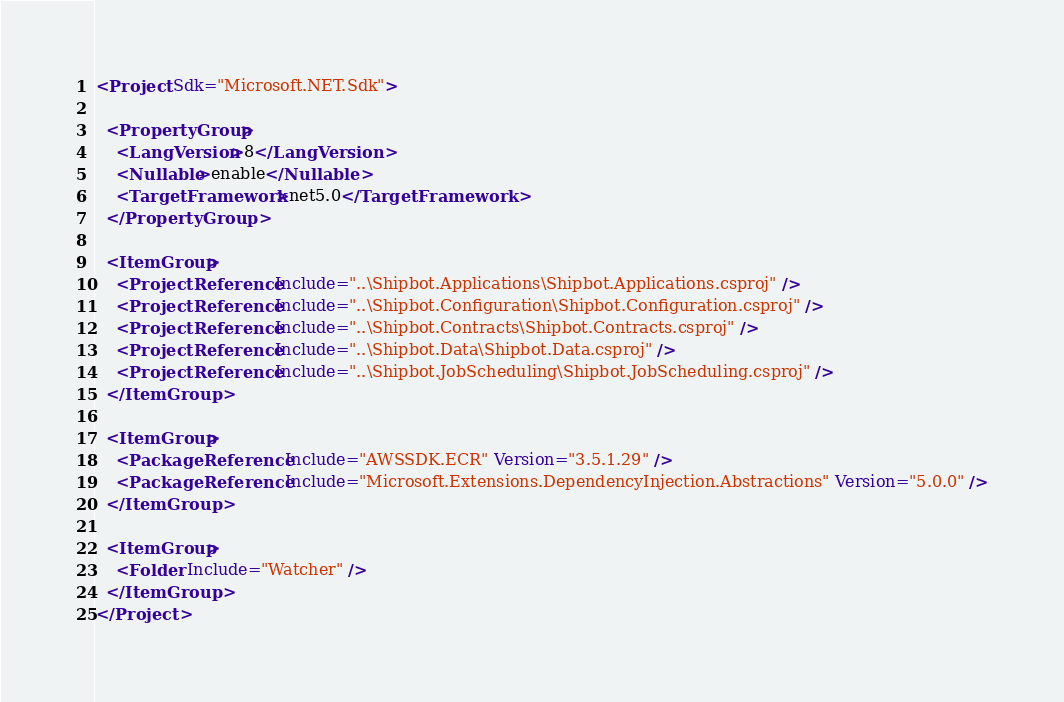Convert code to text. <code><loc_0><loc_0><loc_500><loc_500><_XML_><Project Sdk="Microsoft.NET.Sdk">

  <PropertyGroup>
    <LangVersion>8</LangVersion>
    <Nullable>enable</Nullable>
    <TargetFramework>net5.0</TargetFramework>
  </PropertyGroup>

  <ItemGroup>
    <ProjectReference Include="..\Shipbot.Applications\Shipbot.Applications.csproj" />
    <ProjectReference Include="..\Shipbot.Configuration\Shipbot.Configuration.csproj" />
    <ProjectReference Include="..\Shipbot.Contracts\Shipbot.Contracts.csproj" />
    <ProjectReference Include="..\Shipbot.Data\Shipbot.Data.csproj" />
    <ProjectReference Include="..\Shipbot.JobScheduling\Shipbot.JobScheduling.csproj" />
  </ItemGroup>
  
  <ItemGroup>
    <PackageReference Include="AWSSDK.ECR" Version="3.5.1.29" />
    <PackageReference Include="Microsoft.Extensions.DependencyInjection.Abstractions" Version="5.0.0" />
  </ItemGroup>
  
  <ItemGroup>
    <Folder Include="Watcher" />
  </ItemGroup>
</Project>
</code> 